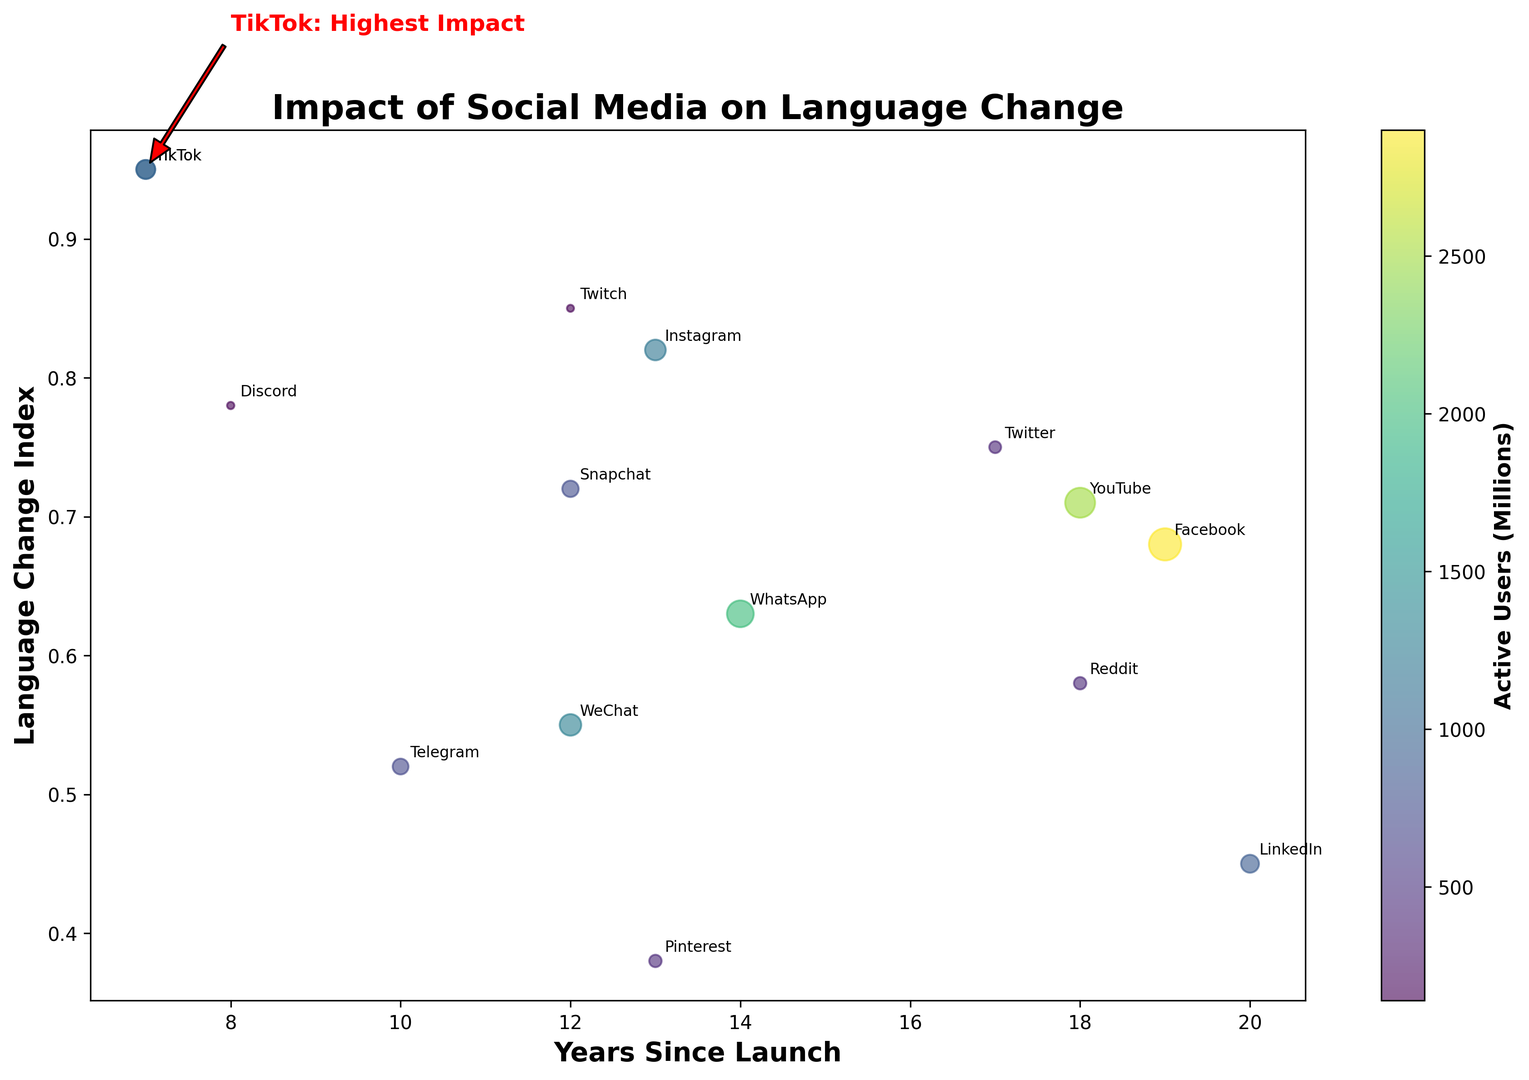Which platform has the highest language change index and how is it annotated on the chart? The platform with the highest language change index is TikTok, with a language change index of 0.95. It is annotated with "TikTok: Highest Impact" in red with an arrow pointing to its data point.
Answer: TikTok Compare the language change index between Instagram and Snapchat. Which one is higher and by how much? Instagram has a language change index of 0.82, while Snapchat has 0.72. To find the difference, subtract Snapchat's index from Instagram's index: 0.82 - 0.72 = 0.10. Therefore, Instagram's language change index is higher by 0.10.
Answer: Instagram by 0.10 What is the color associated with the smallest and largest number of active users? The color bar indicates that the smallest number of active users (Twitch with 140 million) is associated with a darker purple hue, while the largest number of active users (Facebook with 2900 million) is associated with a lighter yellow hue.
Answer: Dark purple and light yellow How many years since launch have the platforms with a language change index higher than 0.80 been around? Platforms with a language change index higher than 0.80 are Instagram (13 years), TikTok (7 years), and Twitch (12 years). Summing up these values: 13 + 7 + 12 = 32 years.
Answer: 32 years Which platform has had the least impact on language change and what is its language change index? Pinterest has had the least impact on language change, with a language change index of 0.38.
Answer: Pinterest with 0.38 Between Facebook and LinkedIn, which one has more active users and by how much? Facebook has 2900 million active users, and LinkedIn has 900 million active users. Subtracting LinkedIn's users from Facebook's users: 2900 - 900 = 2000. Therefore, Facebook has 2000 million more active users than LinkedIn.
Answer: Facebook by 2000 million Which platforms have been in existence for more than 15 years and what are their corresponding language change indices? The platforms that have been in existence for more than 15 years are Facebook (19 years, 0.68 index), Twitter (17 years, 0.75 index), LinkedIn (20 years, 0.45 index), Reddit (18 years, 0.58 index), and YouTube (18 years, 0.71 index).
Answer: Facebook (0.68), Twitter (0.75), LinkedIn (0.45), Reddit (0.58), YouTube (0.71) What is the average language change index of the platforms launched within the last 10 years? The platforms launched within the last 10 years are TikTok (0.95), Telegram (0.52), Discord (0.78), and Twitch (0.85). Summing their language change indices: 0.95 + 0.52 + 0.78 + 0.85 = 3.10. Dividing by the number of platforms: 3.10 / 4 = 0.775.
Answer: 0.775 Which platform has the closest language change index to YouTube, and what is the value? YouTube has a language change index of 0.71. The closest platform is Facebook with a language change index of 0.68.
Answer: Facebook with 0.68 What visual feature is used to represent the number of active users in the scatter plot, and how does it vary? The size of the circles in the scatter plot represents the number of active users, with larger circles indicating more active users.
Answer: Circle size 